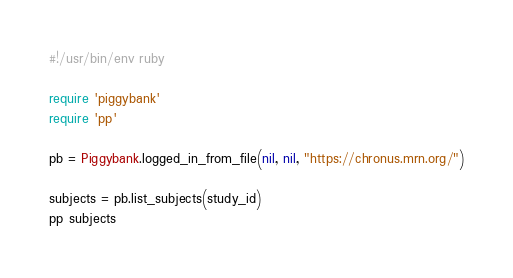<code> <loc_0><loc_0><loc_500><loc_500><_Ruby_>#!/usr/bin/env ruby

require 'piggybank'
require 'pp'

pb = Piggybank.logged_in_from_file(nil, nil, "https://chronus.mrn.org/")

subjects = pb.list_subjects(study_id)
pp subjects
</code> 